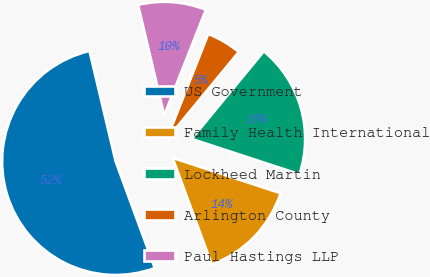<chart> <loc_0><loc_0><loc_500><loc_500><pie_chart><fcel>US Government<fcel>Family Health International<fcel>Lockheed Martin<fcel>Arlington County<fcel>Paul Hastings LLP<nl><fcel>51.9%<fcel>14.37%<fcel>19.06%<fcel>4.99%<fcel>9.68%<nl></chart> 